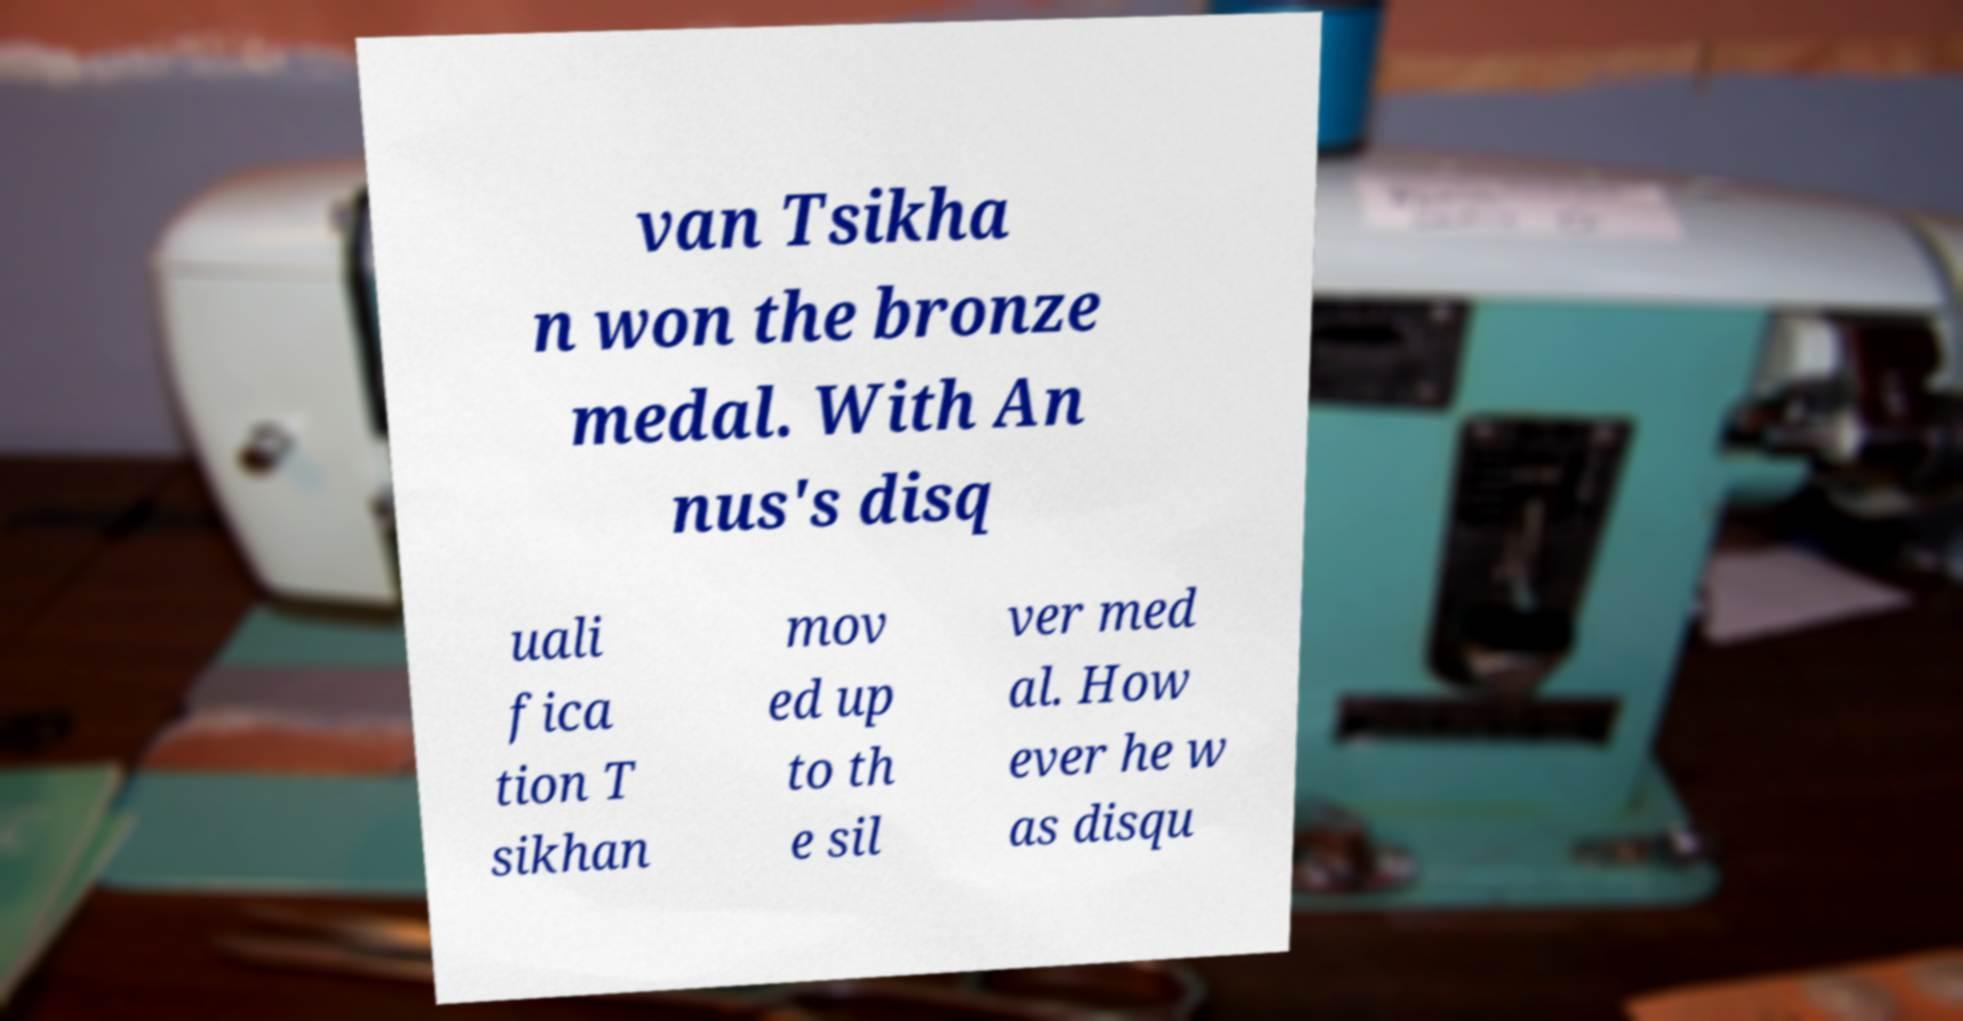There's text embedded in this image that I need extracted. Can you transcribe it verbatim? van Tsikha n won the bronze medal. With An nus's disq uali fica tion T sikhan mov ed up to th e sil ver med al. How ever he w as disqu 